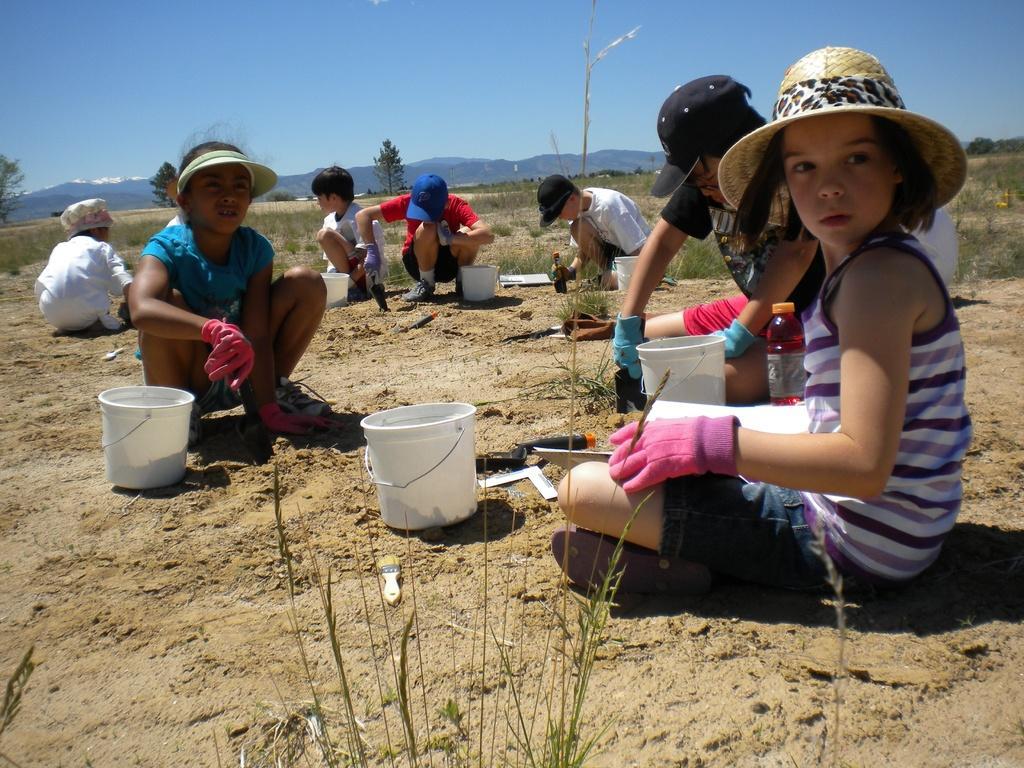Can you describe this image briefly? In this image I can see group of people sitting, in front the person is wearing pink color gloves and holding a brush and few papers. I can also see few buckets and bottles. I can see trees in green color and the sky is in blue color. 